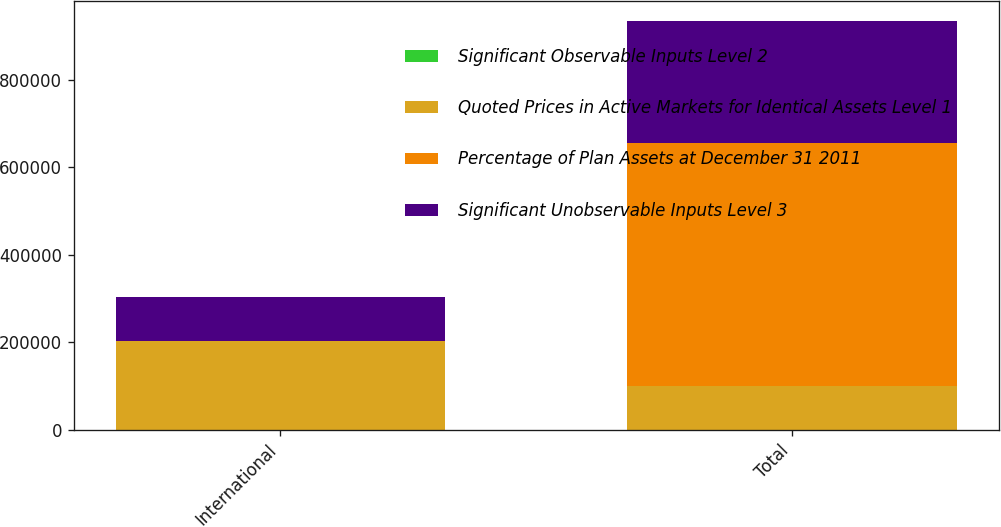Convert chart to OTSL. <chart><loc_0><loc_0><loc_500><loc_500><stacked_bar_chart><ecel><fcel>International<fcel>Total<nl><fcel>Significant Observable Inputs Level 2<fcel>22<fcel>100<nl><fcel>Quoted Prices in Active Markets for Identical Assets Level 1<fcel>202917<fcel>100745<nl><fcel>Percentage of Plan Assets at December 31 2011<fcel>26<fcel>554358<nl><fcel>Significant Unobservable Inputs Level 3<fcel>100745<fcel>278136<nl></chart> 